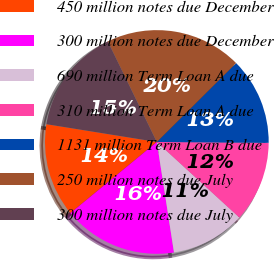Convert chart to OTSL. <chart><loc_0><loc_0><loc_500><loc_500><pie_chart><fcel>450 million notes due December<fcel>300 million notes due December<fcel>690 million Term Loan A due<fcel>310 million Term Loan A due<fcel>1131 million Term Loan B due<fcel>250 million notes due July<fcel>300 million notes due July<nl><fcel>13.5%<fcel>16.49%<fcel>10.75%<fcel>11.67%<fcel>12.58%<fcel>19.76%<fcel>15.24%<nl></chart> 